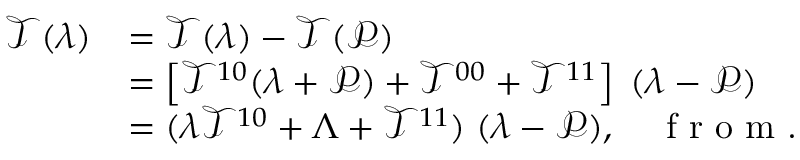Convert formula to latex. <formula><loc_0><loc_0><loc_500><loc_500>\begin{array} { r l } { \mathcal { T } ( \lambda ) } & { = \mathcal { T } ( \lambda ) - \mathcal { T } ( \mathcal { P } ) } \\ & { = \left [ \mathcal { T } ^ { 1 0 } ( \lambda + \mathcal { P } ) + \mathcal { T } ^ { 0 0 } + \mathcal { T } ^ { 1 1 } \right ] \, ( \lambda - \mathcal { P } ) } \\ & { = ( \lambda \mathcal { T } ^ { 1 0 } + \Lambda + \mathcal { T } ^ { 1 1 } ) \, ( \lambda - \mathcal { P } ) , \quad f r o m . } \end{array}</formula> 